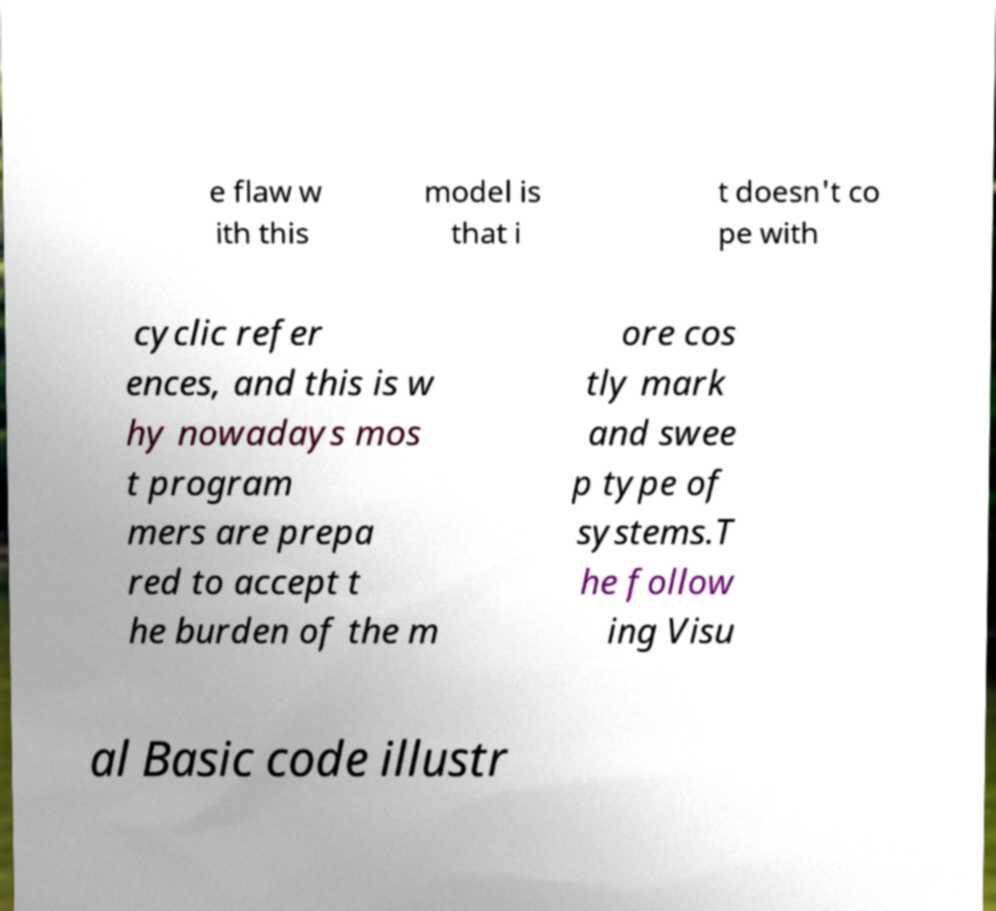Please read and relay the text visible in this image. What does it say? e flaw w ith this model is that i t doesn't co pe with cyclic refer ences, and this is w hy nowadays mos t program mers are prepa red to accept t he burden of the m ore cos tly mark and swee p type of systems.T he follow ing Visu al Basic code illustr 